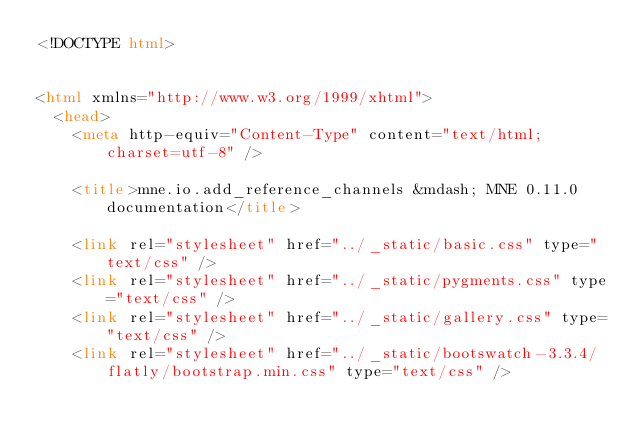Convert code to text. <code><loc_0><loc_0><loc_500><loc_500><_HTML_><!DOCTYPE html>


<html xmlns="http://www.w3.org/1999/xhtml">
  <head>
    <meta http-equiv="Content-Type" content="text/html; charset=utf-8" />
    
    <title>mne.io.add_reference_channels &mdash; MNE 0.11.0 documentation</title>
    
    <link rel="stylesheet" href="../_static/basic.css" type="text/css" />
    <link rel="stylesheet" href="../_static/pygments.css" type="text/css" />
    <link rel="stylesheet" href="../_static/gallery.css" type="text/css" />
    <link rel="stylesheet" href="../_static/bootswatch-3.3.4/flatly/bootstrap.min.css" type="text/css" /></code> 